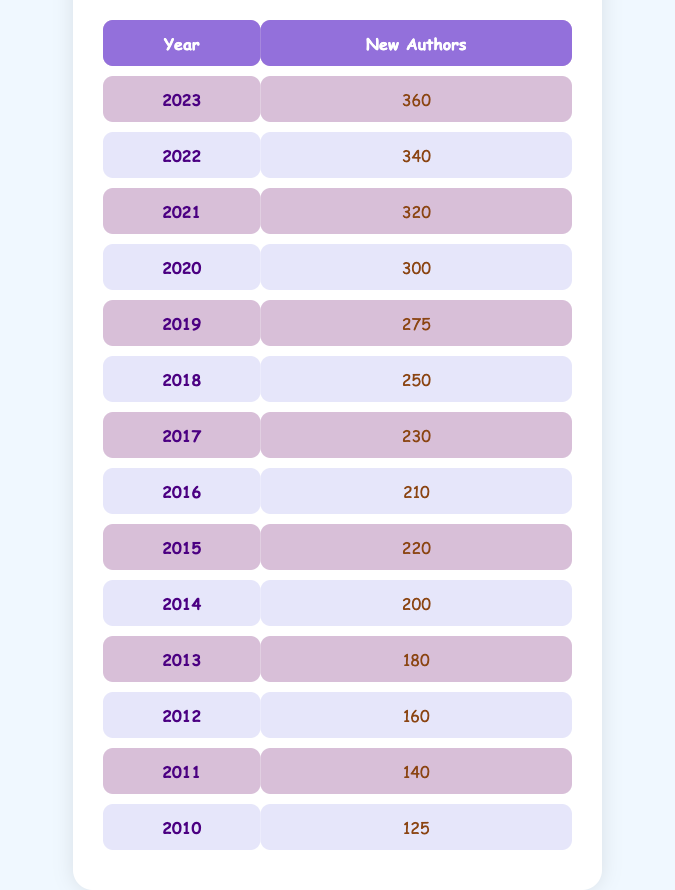What was the number of new authors published in 2010? The table shows the row for the year 2010, which indicates that the number of new authors published that year was 125.
Answer: 125 In which year did the number of new authors first exceed 200? By examining the table, we see that the year 2014 had 200 new authors, and the following year, 2015, had 220, which is the first year the number exceeded 200.
Answer: 2015 What is the total number of new authors published from 2010 to 2015? To find the total, we add the new authors for each year from 2010 to 2015: 125 + 140 + 160 + 180 + 200 + 220 = 1025.
Answer: 1025 Did the number of new authors increase every year from 2010 to 2023? If we look at the table, all the years show an increase in the number of new authors except for 2016, which had a decrease from 220 in 2015 to 210. Therefore, the statement is false.
Answer: No What was the average number of new authors in the years 2012 to 2016? First, we’ll find the total for the years 2012 (160) through 2016 (210): 160 + 180 + 200 + 220 + 210 = 1080. There are 5 years in this range, so we divide 1080 by 5 to get the average, which is 216.
Answer: 216 In 2020, how many more authors were published than in 2015? The table shows that in 2020 there were 300 new authors and in 2015 there were 220. To find the difference, we subtract 220 from 300, resulting in 80 more authors in 2020.
Answer: 80 Which year had the highest number of new authors? Looking through the table, the year 2023 shows the highest number of new authors at 360.
Answer: 2023 Was the increase in new authors from 2018 to 2019 greater than from 2019 to 2020? The increase from 2018 to 2019 was 275 - 250 = 25. Meanwhile, from 2019 to 2020, it was 300 - 275 = 25. Both increases were equal, so the answer is false.
Answer: No 